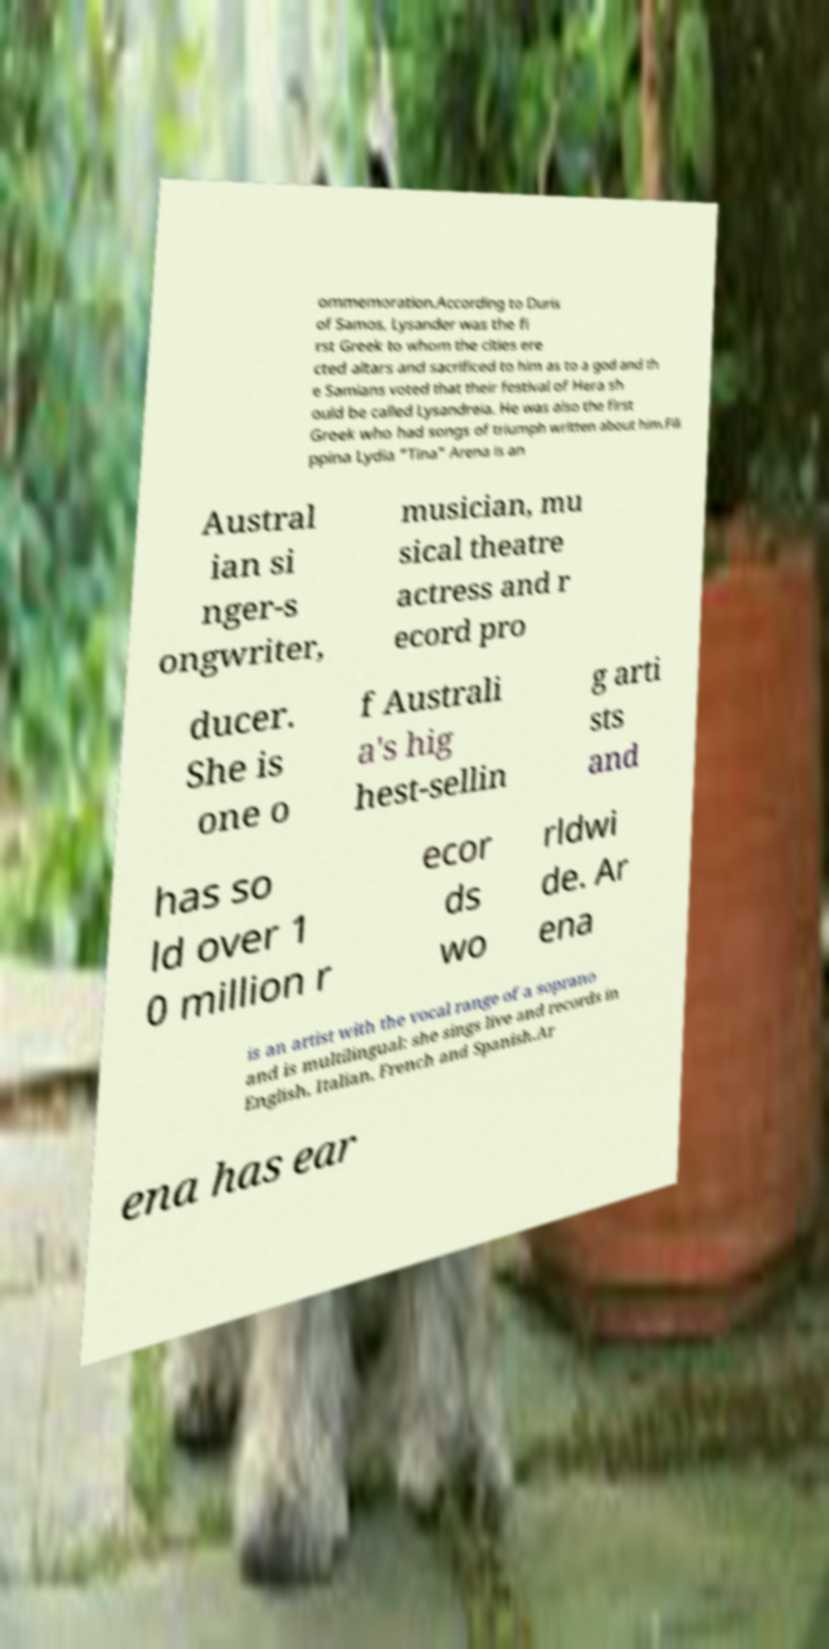Please identify and transcribe the text found in this image. ommemoration.According to Duris of Samos, Lysander was the fi rst Greek to whom the cities ere cted altars and sacrificed to him as to a god and th e Samians voted that their festival of Hera sh ould be called Lysandreia. He was also the first Greek who had songs of triumph written about him.Fili ppina Lydia "Tina" Arena is an Austral ian si nger-s ongwriter, musician, mu sical theatre actress and r ecord pro ducer. She is one o f Australi a's hig hest-sellin g arti sts and has so ld over 1 0 million r ecor ds wo rldwi de. Ar ena is an artist with the vocal range of a soprano and is multilingual: she sings live and records in English, Italian, French and Spanish.Ar ena has ear 